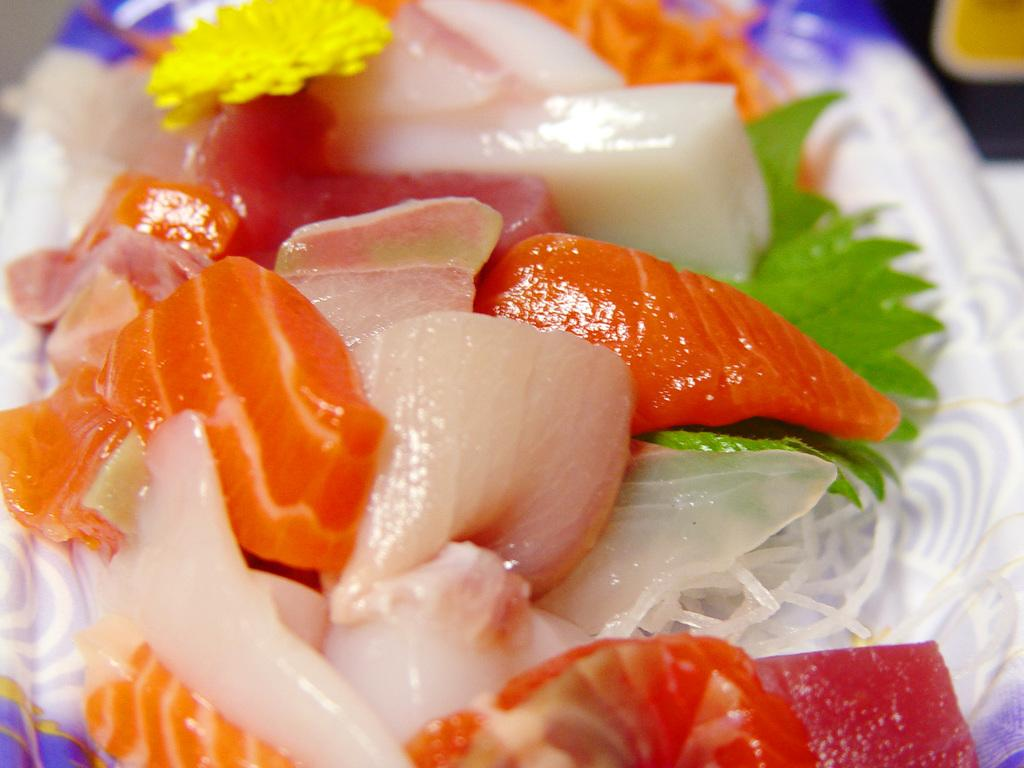What is on the plate in the image? There are food items on a plate in the image. Can you describe the object at the top right corner of the image? Unfortunately, the provided facts do not give enough information to describe the object at the top right corner of the image. What type of polish is being applied to the food items in the image? There is no polish being applied to the food items in the image. Can you tell me who is winning the argument in the image? There is no argument present in the image, so it is not possible to determine who might be winning. 